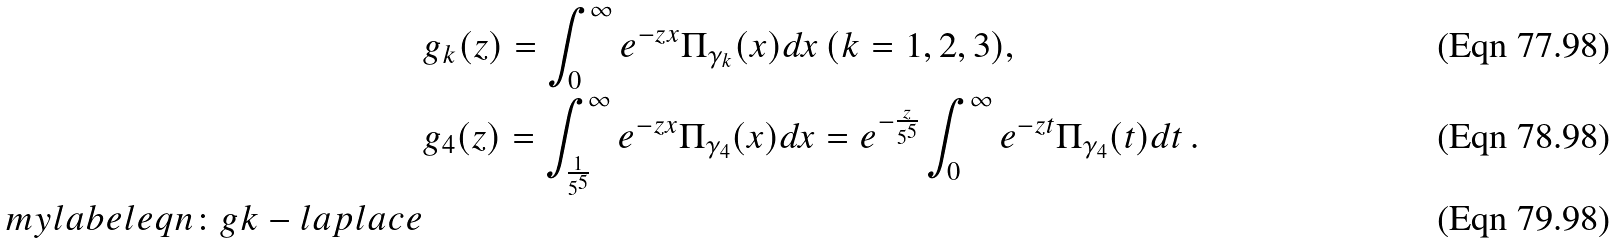Convert formula to latex. <formula><loc_0><loc_0><loc_500><loc_500>& g _ { k } ( z ) = \int _ { 0 } ^ { \infty } e ^ { - z x } \Pi _ { \gamma _ { k } } ( x ) d x \, ( k = 1 , 2 , 3 ) , \\ & g _ { 4 } ( z ) = \int _ { \frac { 1 } { 5 ^ { 5 } } } ^ { \infty } e ^ { - z x } \Pi _ { \gamma _ { 4 } } ( x ) d x = e ^ { - \frac { z } { 5 ^ { 5 } } } \int _ { 0 } ^ { \infty } e ^ { - z t } \Pi _ { \gamma _ { 4 } } ( t ) d t \, . \\ \ m y l a b e l { e q n \colon g k - l a p l a c e }</formula> 